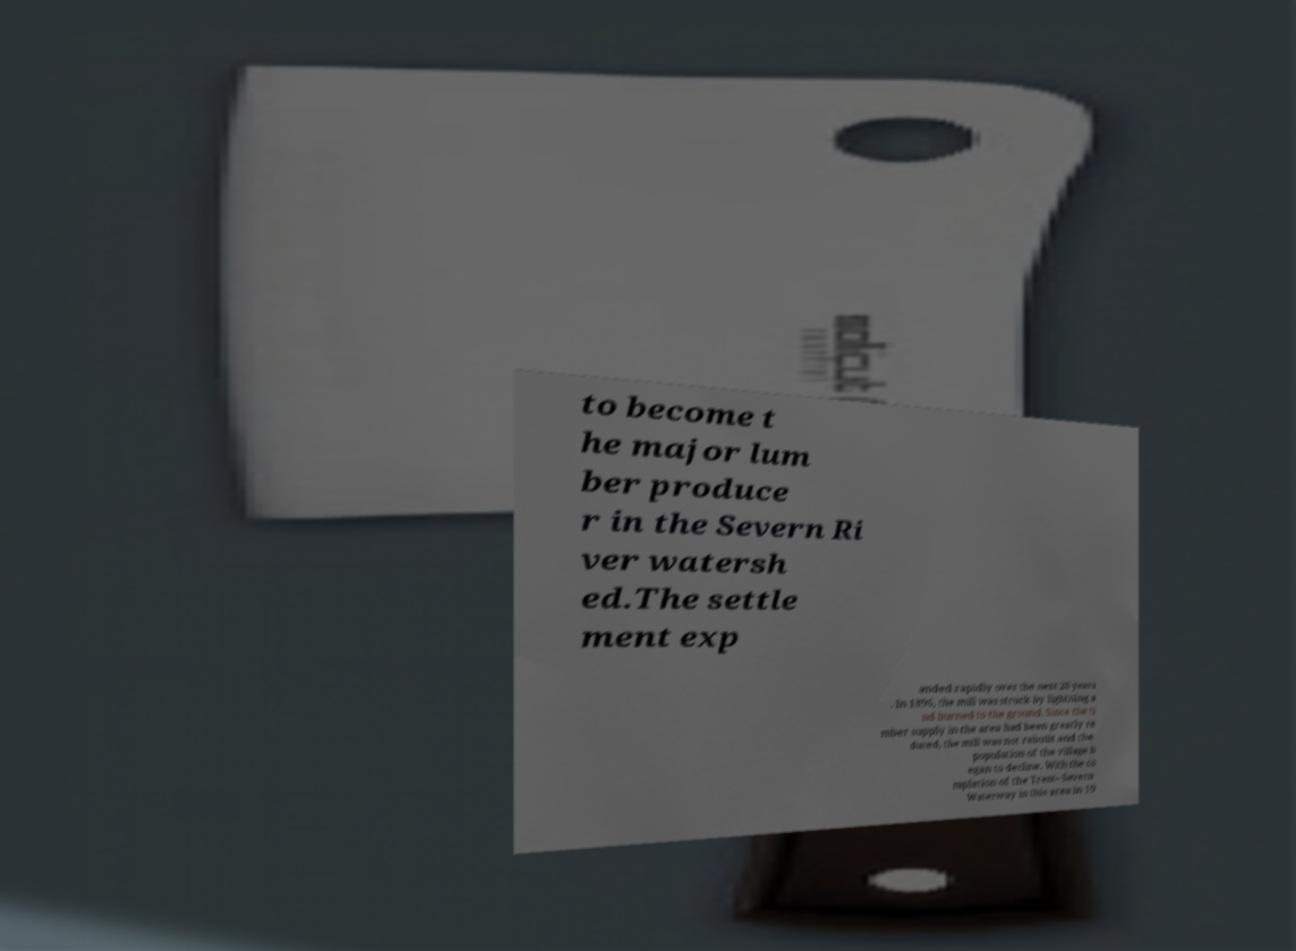Please read and relay the text visible in this image. What does it say? to become t he major lum ber produce r in the Severn Ri ver watersh ed.The settle ment exp anded rapidly over the next 20 years . In 1896, the mill was struck by lightning a nd burned to the ground. Since the ti mber supply in the area had been greatly re duced, the mill was not rebuilt and the population of the village b egan to decline. With the co mpletion of the Trent–Severn Waterway in this area in 19 